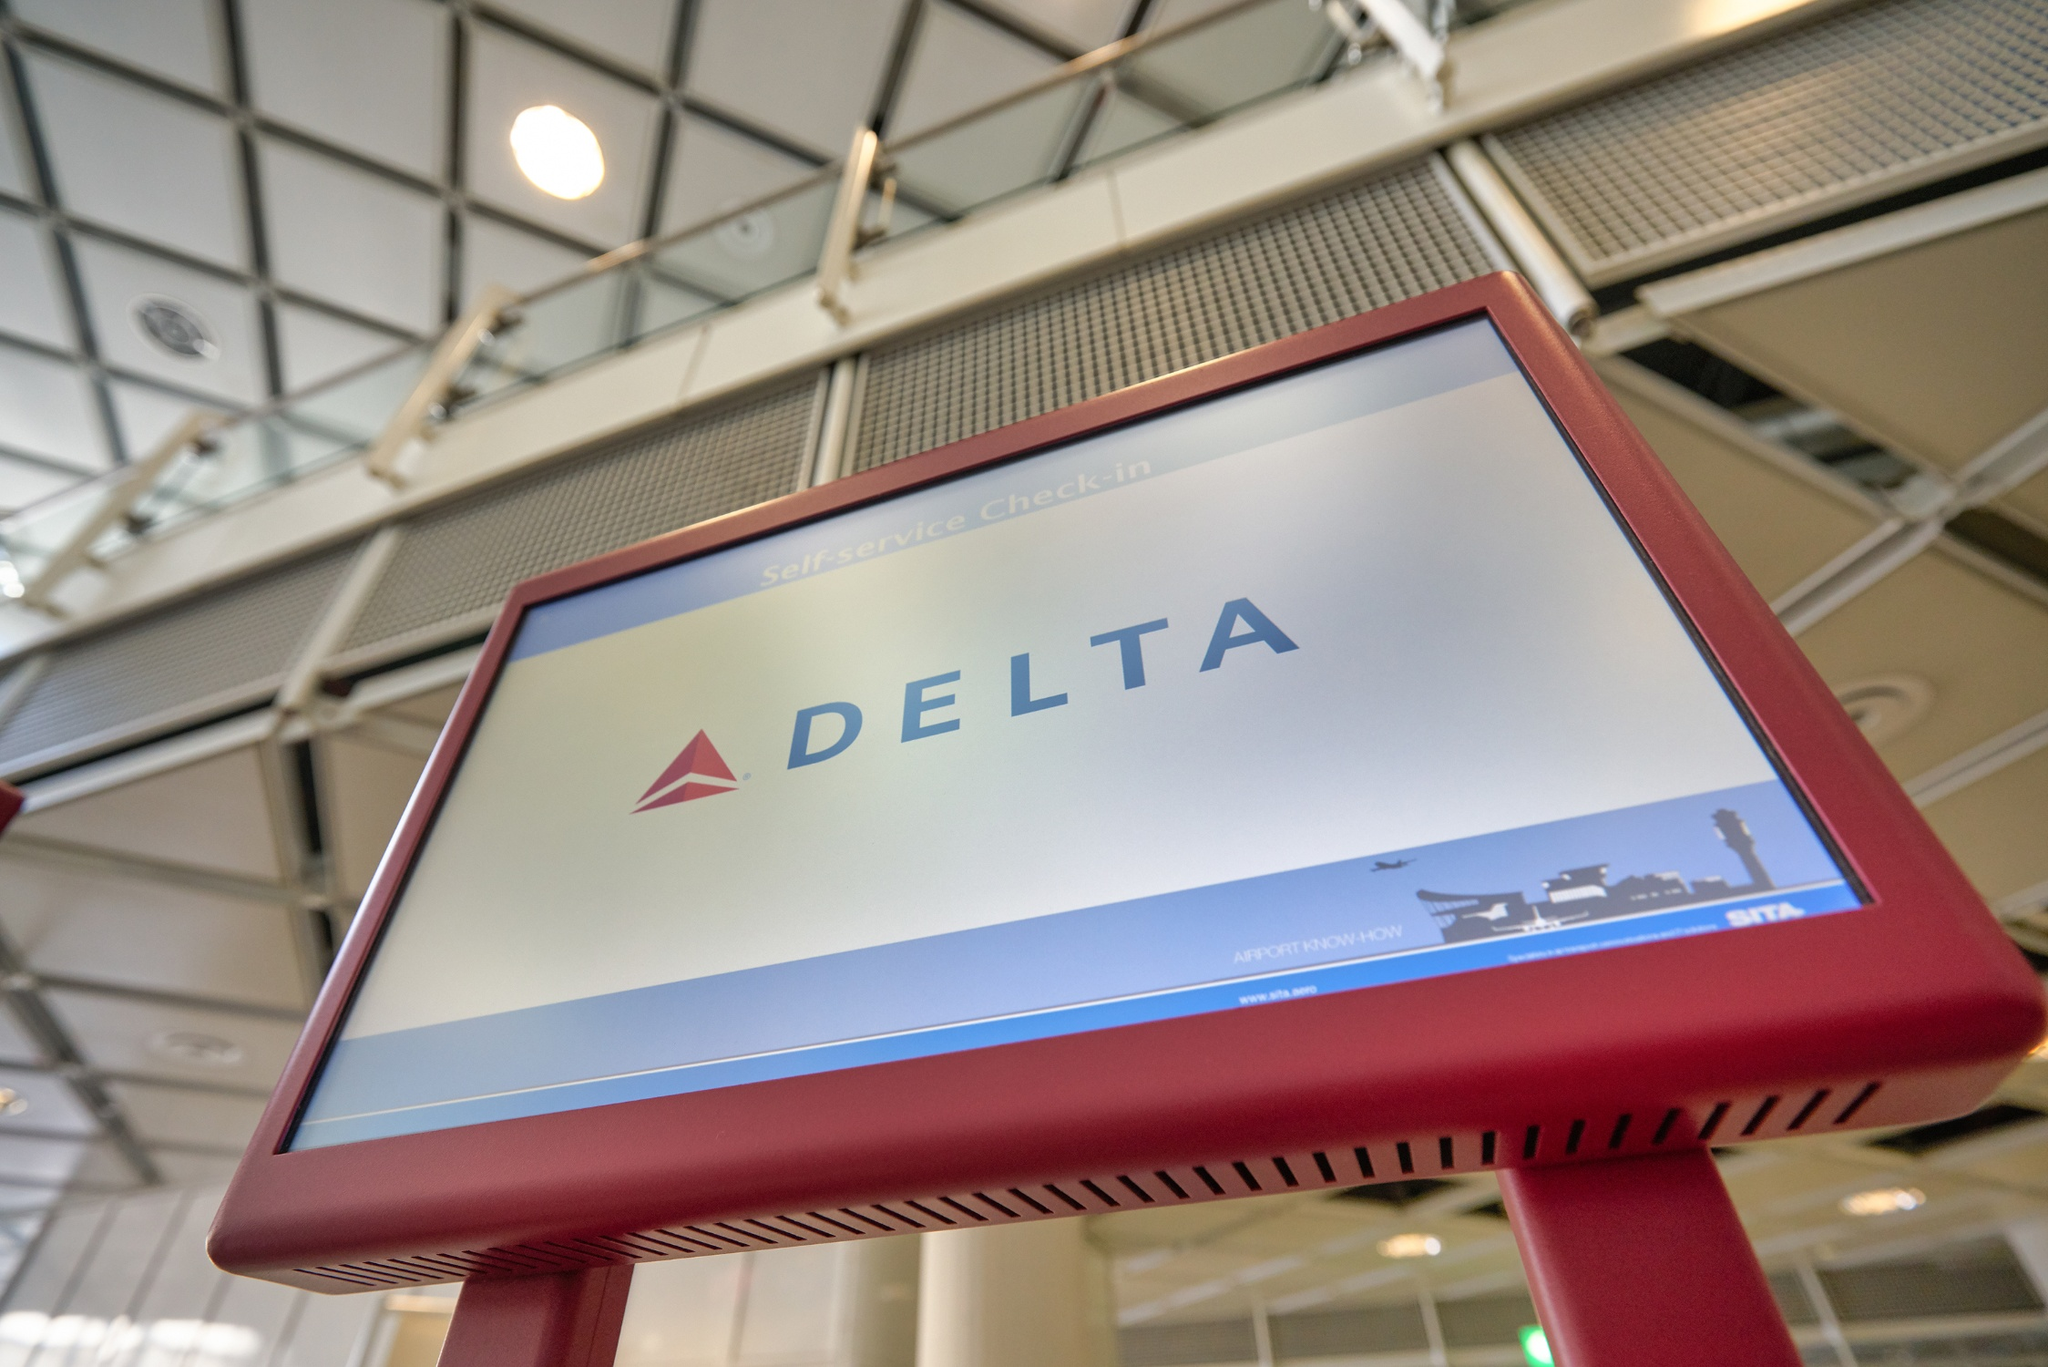Imagine a traveler using this kiosk. Describe their interaction and any potential issues they might face. A traveler approaches the Delta self-service check-in kiosk, perhaps pushing a luggage cart with their belongings. They tap the screen to start the check-in process, following the on-screen prompts to enter their booking details. The kiosk responds quickly, guiding the traveler through each step, including selecting their seat and printing their boarding pass. Potential issues that might arise could include technical glitches if the kiosk fails to read their booking code, or if the traveler needs assistance with a special request not covered by the self-service options. However, the design of the kiosk seems intuitive, aiming to minimize such problems. 